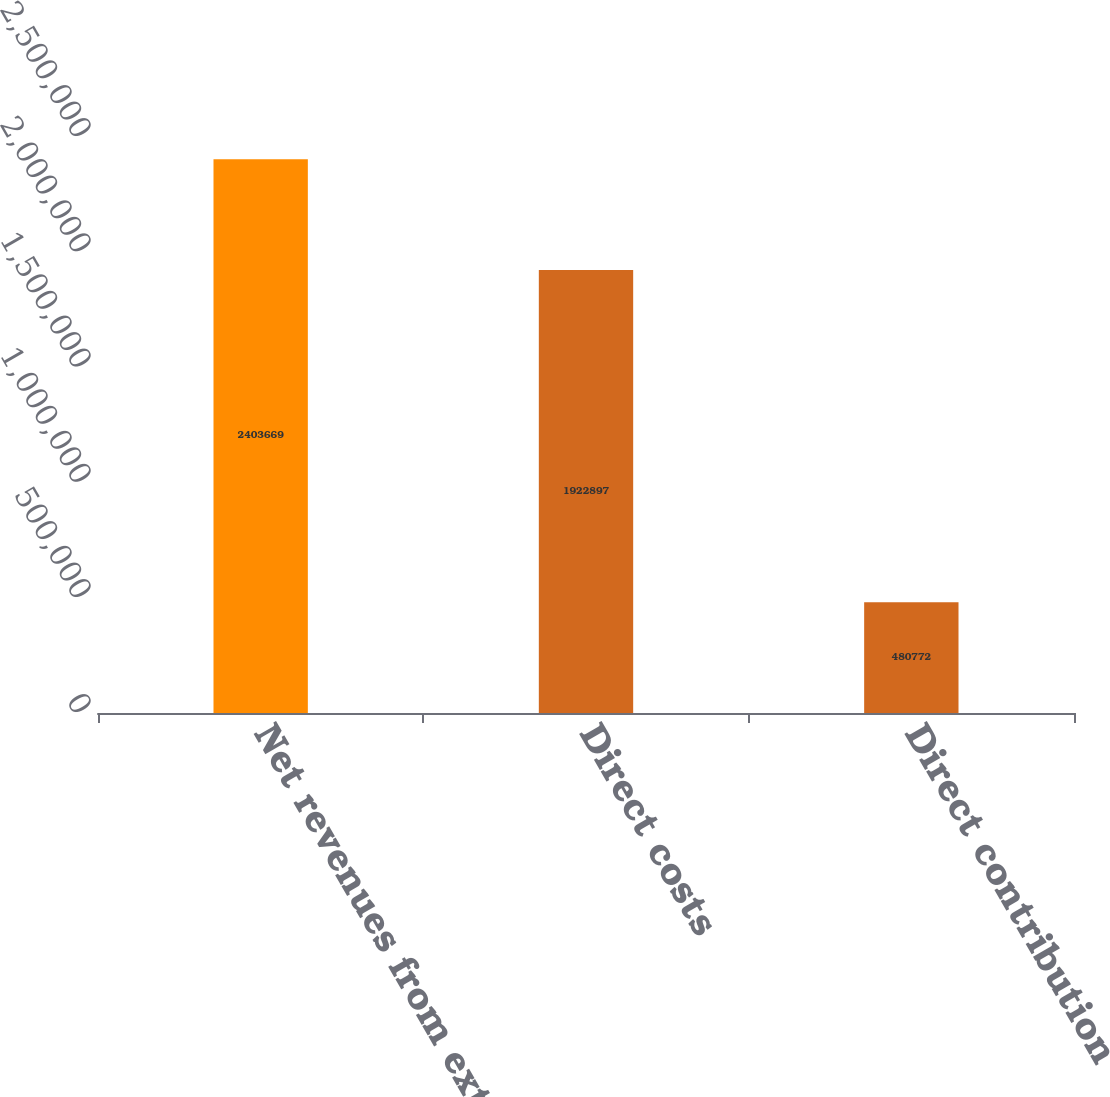Convert chart. <chart><loc_0><loc_0><loc_500><loc_500><bar_chart><fcel>Net revenues from external<fcel>Direct costs<fcel>Direct contribution<nl><fcel>2.40367e+06<fcel>1.9229e+06<fcel>480772<nl></chart> 